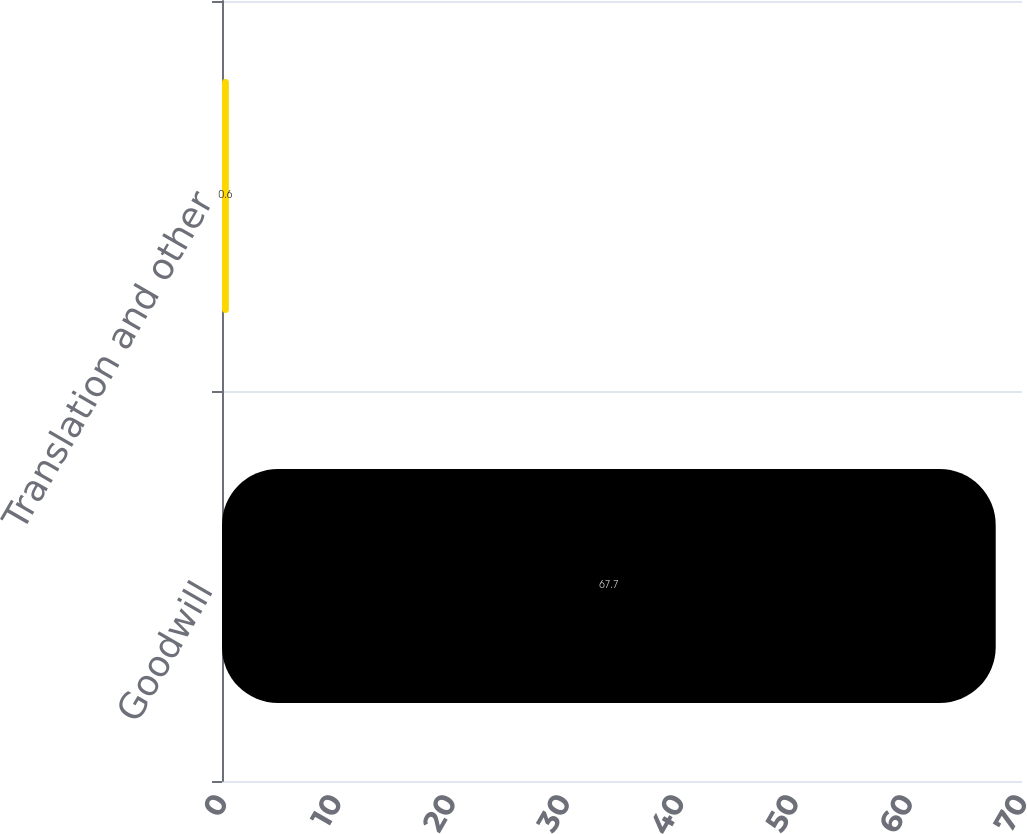<chart> <loc_0><loc_0><loc_500><loc_500><bar_chart><fcel>Goodwill<fcel>Translation and other<nl><fcel>67.7<fcel>0.6<nl></chart> 